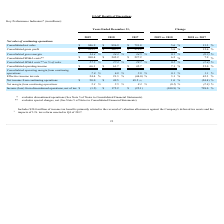From Systemax's financial document, What is the change in consolidated net sales between 2019 vs 2018 and 2018 vs 2017 respectively? The document shows two values: 5.6% and 13.3%. From the document: "Consolidated net sales $ 946.9 $ 896.9 $ 791.8 5.6 % 13.3 % solidated net sales $ 946.9 $ 896.9 $ 791.8 5.6 % 13.3 %..." Also, What is the change in consolidated gross profits between 2019 vs 2018 and 2018 vs 2017 respectively? The document shows two values: 5.8% and 12.6%. From the document: "idated gross profit $ 325.7 $ 307.7 $ 273.2 5.8 % 12.6 % Consolidated gross profit $ 325.7 $ 307.7 $ 273.2 5.8 % 12.6 %..." Also, What is the change in consolidated gross margins between 2019 vs 2018 and 2018 vs 2017 respectively? The document shows two values: 0.1% and (0.2)%. From the document: "nsolidated gross margin 34.4 % 34.3 % 34.5 % 0.1 % (0.2) % Consolidated gross margin 34.4 % 34.3 % 34.5 % 0.1 % (0.2) %..." Also, can you calculate: What is the total consolidated net sales in 2019 and 2018? Based on the calculation: 946.9 +896.9 , the result is 1843.8 (in millions). This is based on the information: "Consolidated net sales $ 946.9 $ 896.9 $ 791.8 5.6 % 13.3 % Consolidated net sales $ 946.9 $ 896.9 $ 791.8 5.6 % 13.3 %..." The key data points involved are: 896.9, 946.9. Also, can you calculate: What is the total consolidated net sales in 2017 and 2018 Based on the calculation: 896.9 + 791.8 , the result is 1688.7 (in millions). This is based on the information: "Consolidated net sales $ 946.9 $ 896.9 $ 791.8 5.6 % 13.3 % Consolidated net sales $ 946.9 $ 896.9 $ 791.8 5.6 % 13.3 %..." The key data points involved are: 791.8, 896.9. Also, can you calculate: What is the change in consolidated gross profit between 2017 and 2018? Based on the calculation: 307.7 - 273.2 , the result is 34.5 (in millions). This is based on the information: "Consolidated gross profit $ 325.7 $ 307.7 $ 273.2 5.8 % 12.6 % Consolidated gross profit $ 325.7 $ 307.7 $ 273.2 5.8 % 12.6 %..." The key data points involved are: 273.2, 307.7. 